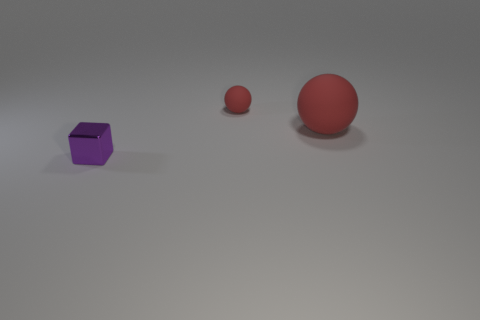Subtract all red balls. How many were subtracted if there are1red balls left? 1 Subtract all brown blocks. Subtract all cyan cylinders. How many blocks are left? 1 Add 2 cyan balls. How many objects exist? 5 Subtract all blocks. How many objects are left? 2 Add 1 purple metallic cubes. How many purple metallic cubes exist? 2 Subtract 2 red balls. How many objects are left? 1 Subtract all rubber objects. Subtract all small green shiny things. How many objects are left? 1 Add 2 large red rubber spheres. How many large red rubber spheres are left? 3 